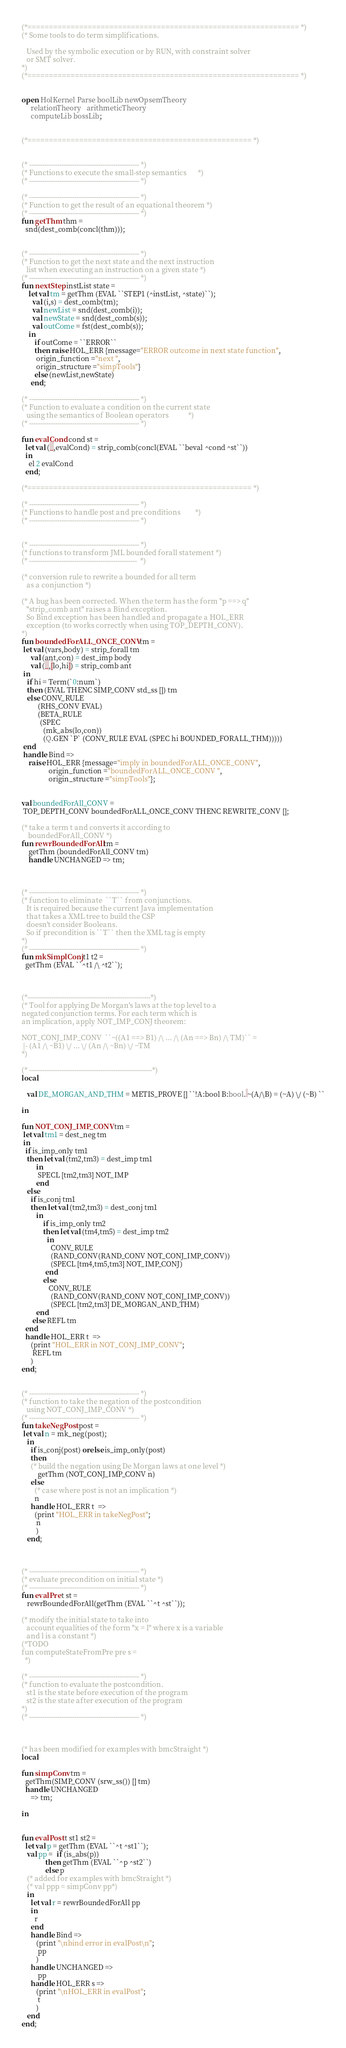<code> <loc_0><loc_0><loc_500><loc_500><_SML_>(*=============================================================== *)
(* Some tools to do term simplifications.

   Used by the symbolic execution or by RUN, with constraint solver
   or SMT solver.
*)
(*=============================================================== *)


open HolKernel Parse boolLib newOpsemTheory
     relationTheory   arithmeticTheory
     computeLib bossLib;


(*==================================================== *)


(* --------------------------------------------------- *)
(* Functions to execute the small-step semantics       *)
(* --------------------------------------------------- *)

(* --------------------------------------------------- *)
(* Function to get the result of an equational theorem *)
(* --------------------------------------------------- *)
fun getThm thm =
  snd(dest_comb(concl(thm)));


(* --------------------------------------------------- *)
(* Function to get the next state and the next instruction
   list when executing an instruction on a given state *)
(* --------------------------------------------------- *)
fun nextStep instList state =
    let val tm = getThm (EVAL ``STEP1 (^instList, ^state)``);
      val (i,s) = dest_comb(tm);
      val newList = snd(dest_comb(i));
      val newState = snd(dest_comb(s));
      val outCome = fst(dest_comb(s));
    in
       if outCome = ``ERROR``
       then raise HOL_ERR {message="ERROR outcome in next state function",
		origin_function ="next ",
		origin_structure ="simpTools"}
       else (newList,newState)
     end;

(* --------------------------------------------------- *)
(* Function to evaluate a condition on the current state
   using the semantics of Boolean operators            *)
(* --------------------------------------------------- *)

fun evalCond cond st =
  let val (_,evalCond) = strip_comb(concl(EVAL ``beval ^cond ^st``))
  in
    el 2 evalCond
  end;

(*==================================================== *)

(* --------------------------------------------------- *)
(* Functions to handle post and pre conditions         *)
(* --------------------------------------------------- *)


(* --------------------------------------------------- *)
(* functions to transform JML bounded forall statement *)
(* --------------------------------------------------  *)

(* conversion rule to rewrite a bounded for all term
   as a conjunction *)

(* A bug has been corrected. When the term has the form "p ==> q"
   "strip_comb ant" raises a Bind exception.
   So Bind exception has been handled and propagate a HOL_ERR
   exception (to works correctly when using TOP_DEPTH_CONV).
*)
fun boundedForALL_ONCE_CONV tm =
 let val (vars,body) = strip_forall tm
     val (ant,con) = dest_imp body
     val (_,[lo,hi]) = strip_comb ant
 in
   if hi = Term(`0:num`)
   then (EVAL THENC SIMP_CONV std_ss []) tm
   else CONV_RULE
         (RHS_CONV EVAL)
         (BETA_RULE
          (SPEC
            (mk_abs(lo,con))
            (Q.GEN `P` (CONV_RULE EVAL (SPEC hi BOUNDED_FORALL_THM)))))
 end
 handle Bind =>
	raise HOL_ERR {message="imply in boundedForALL_ONCE_CONV",
		       origin_function ="boundedForALL_ONCE_CONV ",
		       origin_structure ="simpTools"};


val boundedForAll_CONV =
 TOP_DEPTH_CONV boundedForALL_ONCE_CONV THENC REWRITE_CONV [];

(* take a term t and converts it according to
    boundedForAll_CONV *)
fun rewrBoundedForAll tm =
    getThm (boundedForAll_CONV tm)
    handle UNCHANGED => tm;



(* --------------------------------------------------- *)
(* function to eliminate  ``T`` from conjunctions.
   It is required because the current Java implementation
   that takes a XML tree to build the CSP
   doesn't consider Booleans.
   So if precondition is ``T`` then the XML tag is empty
*)
(* --------------------------------------------------- *)
fun mkSimplConj t1 t2 =
  getThm (EVAL ``^t1 /\ ^t2``);



(*---------------------------------------------------------*)
(* Tool for applying De Morgan's laws at the top level to a
negated conjunction terms. For each term which is
an implication, apply NOT_IMP_CONJ theorem:

NOT_CONJ_IMP_CONV  ``~((A1 ==> B1) /\ ... /\ (An ==> Bn) /\ TM)`` =
 |- (A1 /\ ~B1) \/ ... \/ (An /\ ~Bn) \/ ~TM
*)

(* ---------------------------------------------------------*)
local

   val DE_MORGAN_AND_THM = METIS_PROVE [] ``!A:bool B:bool. ~(A/\B) = (~A) \/ (~B) ``

in

fun NOT_CONJ_IMP_CONV tm =
 let val tm1 = dest_neg tm
 in
  if is_imp_only tm1
   then let val (tm2,tm3) = dest_imp tm1
        in
         SPECL [tm2,tm3] NOT_IMP
        end
   else
     if is_conj tm1
     then let val (tm2,tm3) = dest_conj tm1
        in
            if is_imp_only tm2
            then let val (tm4,tm5) = dest_imp tm2
              in
                CONV_RULE
                (RAND_CONV(RAND_CONV NOT_CONJ_IMP_CONV))
                (SPECL [tm4,tm5,tm3] NOT_IMP_CONJ)
             end
            else
               CONV_RULE
                (RAND_CONV(RAND_CONV NOT_CONJ_IMP_CONV))
                (SPECL [tm2,tm3] DE_MORGAN_AND_THM)
        end
      else REFL tm
  end
  handle HOL_ERR t  =>
     (print "HOL_ERR in NOT_CONJ_IMP_CONV";
      REFL tm
     )
end;


(* --------------------------------------------------- *)
(* function to take the negation of the postcondition
   using NOT_CONJ_IMP_CONV *)
(* --------------------------------------------------- *)
fun takeNegPost post =
 let val n = mk_neg(post);
   in
     if is_conj(post) orelse is_imp_only(post)
     then
     (* build the negation using De Morgan laws at one level *)
         getThm (NOT_CONJ_IMP_CONV n)
     else
       (* case where post is not an implication *)
       n
     handle HOL_ERR t  =>
       (print "HOL_ERR in takeNegPost";
        n
        )
   end;



(* --------------------------------------------------- *)
(* evaluate precondition on initial state *)
(* --------------------------------------------------- *)
fun evalPre t st =
   rewrBoundedForAll(getThm (EVAL ``^t ^st``));

(* modify the initial state to take into
   account equalities of the form "x = l" where x is a variable
   and l is a constant *)
(*TODO
fun computeStateFromPre pre s =
  *)

(* --------------------------------------------------- *)
(* function to evaluate the postcondition.
   st1 is the state before execution of the program
   st2 is the state after execution of the program
*)
(* --------------------------------------------------- *)



(* has been modified for examples with bmcStraight *)
local

fun simpConv tm =
  getThm(SIMP_CONV (srw_ss()) [] tm)
  handle UNCHANGED
     => tm;

in


fun evalPost t st1 st2 =
  let val p = getThm (EVAL ``^t ^st1``);
   val pp =  if (is_abs(p))
             then getThm (EVAL ``^p ^st2``)
             else p
   (* added for examples with bmcStraight *)
   (* val ppp = simpConv pp*)
   in
     let val r = rewrBoundedForAll pp
     in
       r
     end
     handle Bind =>
	    (print "\nbind error in evalPost\n";
	     pp
	    )
     handle UNCHANGED =>
	     pp
     handle HOL_ERR s =>
	    (print "\nHOL_ERR in evalPost";
	     t
	    )
   end
end;

</code> 